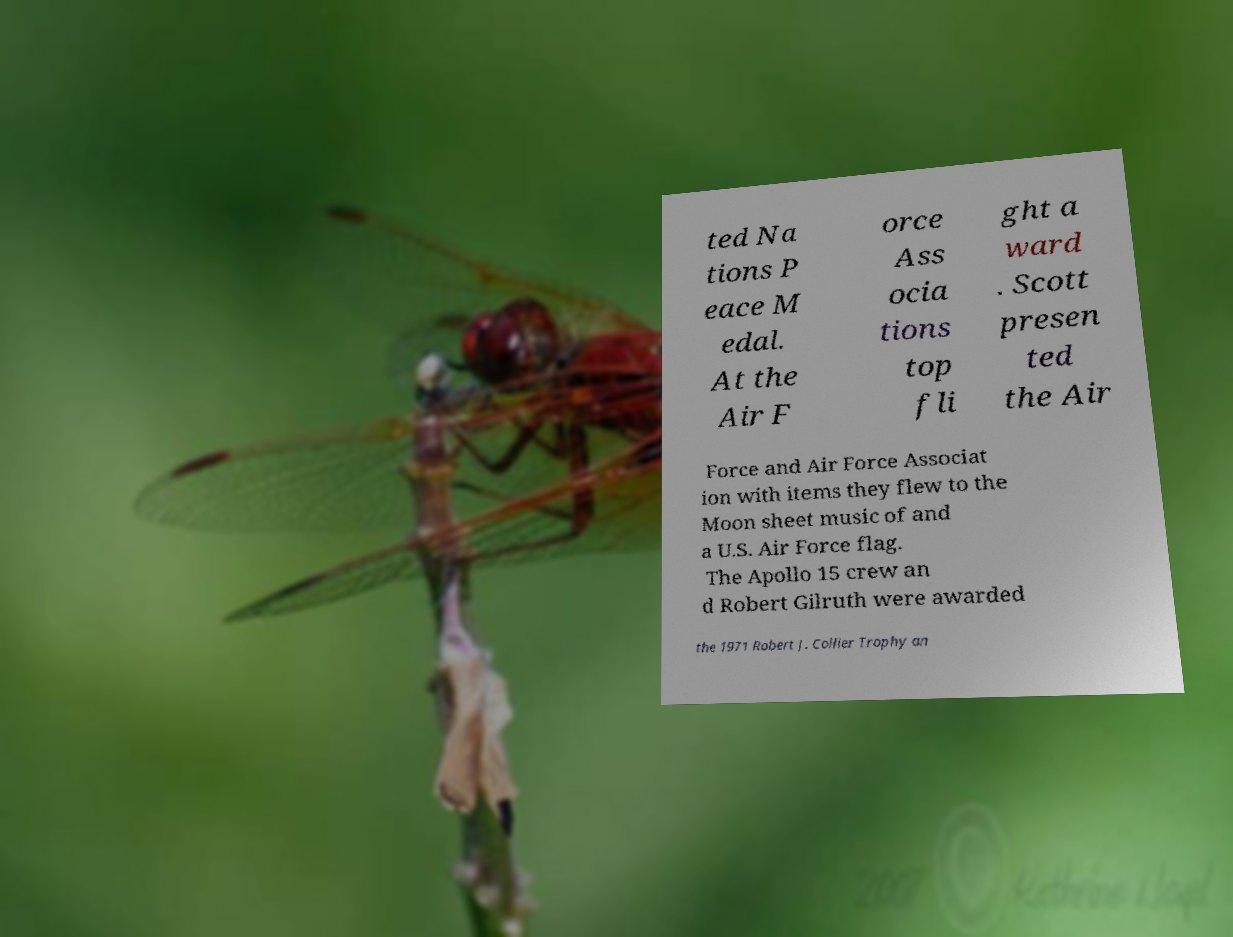There's text embedded in this image that I need extracted. Can you transcribe it verbatim? ted Na tions P eace M edal. At the Air F orce Ass ocia tions top fli ght a ward . Scott presen ted the Air Force and Air Force Associat ion with items they flew to the Moon sheet music of and a U.S. Air Force flag. The Apollo 15 crew an d Robert Gilruth were awarded the 1971 Robert J. Collier Trophy an 